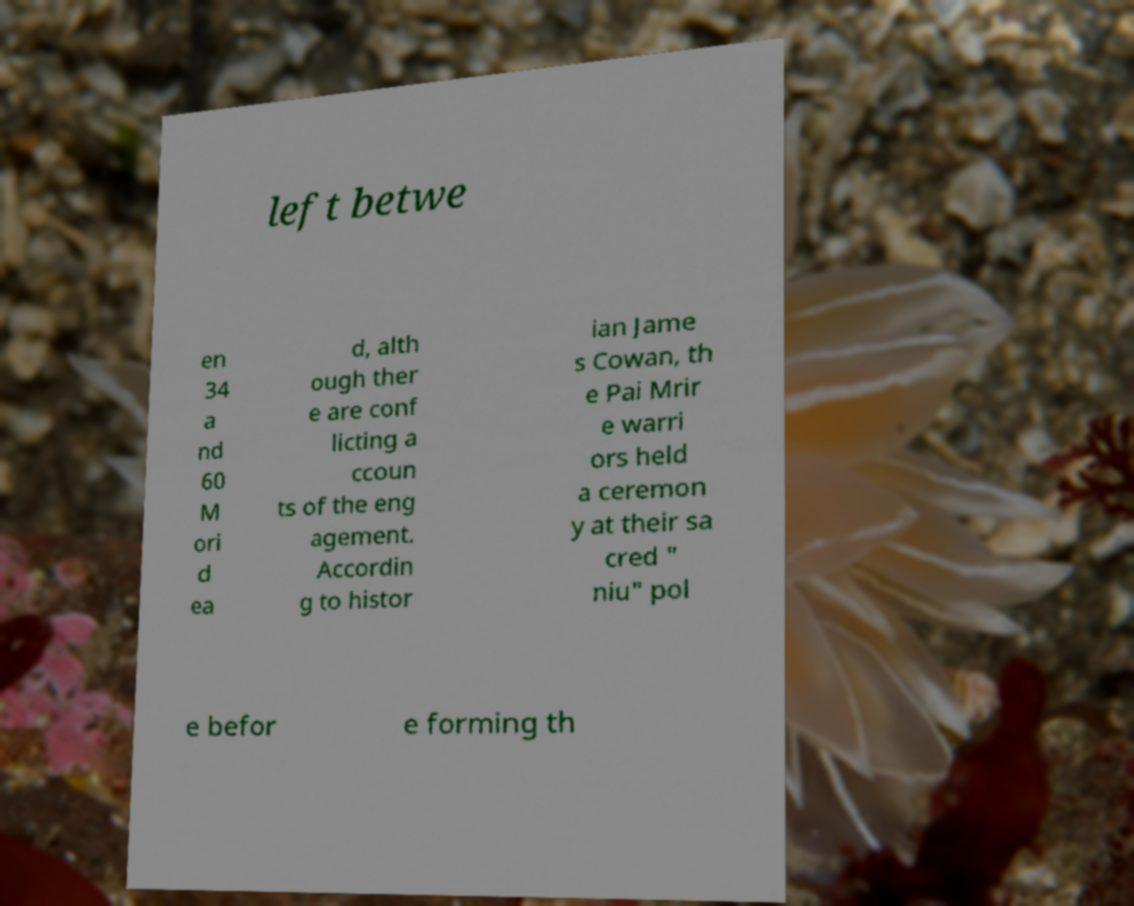Can you accurately transcribe the text from the provided image for me? left betwe en 34 a nd 60 M ori d ea d, alth ough ther e are conf licting a ccoun ts of the eng agement. Accordin g to histor ian Jame s Cowan, th e Pai Mrir e warri ors held a ceremon y at their sa cred " niu" pol e befor e forming th 